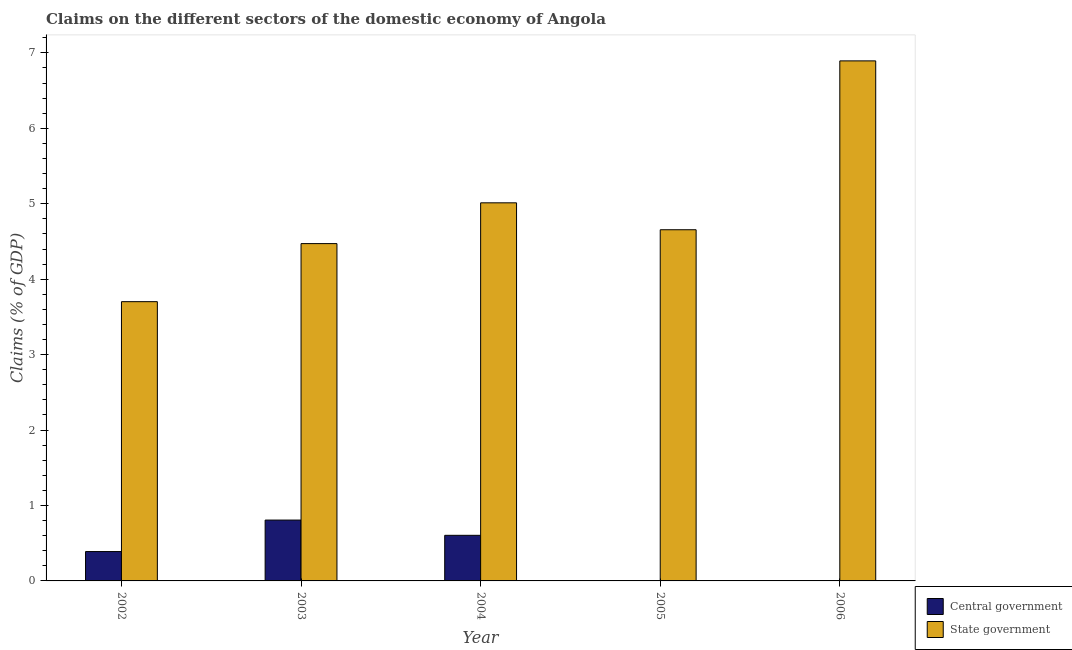How many different coloured bars are there?
Offer a terse response. 2. Are the number of bars on each tick of the X-axis equal?
Offer a very short reply. No. How many bars are there on the 4th tick from the left?
Provide a succinct answer. 1. In how many cases, is the number of bars for a given year not equal to the number of legend labels?
Ensure brevity in your answer.  2. What is the claims on state government in 2005?
Make the answer very short. 4.66. Across all years, what is the maximum claims on state government?
Make the answer very short. 6.89. What is the total claims on central government in the graph?
Give a very brief answer. 1.8. What is the difference between the claims on central government in 2002 and that in 2004?
Provide a succinct answer. -0.22. What is the difference between the claims on central government in 2005 and the claims on state government in 2002?
Give a very brief answer. -0.39. What is the average claims on state government per year?
Your response must be concise. 4.95. What is the ratio of the claims on central government in 2002 to that in 2003?
Your answer should be compact. 0.48. Is the difference between the claims on state government in 2002 and 2003 greater than the difference between the claims on central government in 2002 and 2003?
Provide a short and direct response. No. What is the difference between the highest and the second highest claims on central government?
Your answer should be very brief. 0.2. What is the difference between the highest and the lowest claims on central government?
Ensure brevity in your answer.  0.81. In how many years, is the claims on central government greater than the average claims on central government taken over all years?
Your answer should be compact. 3. How many bars are there?
Provide a succinct answer. 8. How many years are there in the graph?
Make the answer very short. 5. What is the difference between two consecutive major ticks on the Y-axis?
Keep it short and to the point. 1. What is the title of the graph?
Ensure brevity in your answer.  Claims on the different sectors of the domestic economy of Angola. Does "Highest 20% of population" appear as one of the legend labels in the graph?
Your response must be concise. No. What is the label or title of the Y-axis?
Your answer should be compact. Claims (% of GDP). What is the Claims (% of GDP) in Central government in 2002?
Offer a terse response. 0.39. What is the Claims (% of GDP) of State government in 2002?
Make the answer very short. 3.7. What is the Claims (% of GDP) of Central government in 2003?
Provide a succinct answer. 0.81. What is the Claims (% of GDP) in State government in 2003?
Your response must be concise. 4.47. What is the Claims (% of GDP) of Central government in 2004?
Offer a very short reply. 0.6. What is the Claims (% of GDP) in State government in 2004?
Give a very brief answer. 5.01. What is the Claims (% of GDP) of Central government in 2005?
Provide a succinct answer. 0. What is the Claims (% of GDP) of State government in 2005?
Your response must be concise. 4.66. What is the Claims (% of GDP) of Central government in 2006?
Offer a terse response. 0. What is the Claims (% of GDP) in State government in 2006?
Offer a terse response. 6.89. Across all years, what is the maximum Claims (% of GDP) in Central government?
Provide a short and direct response. 0.81. Across all years, what is the maximum Claims (% of GDP) in State government?
Offer a very short reply. 6.89. Across all years, what is the minimum Claims (% of GDP) of Central government?
Give a very brief answer. 0. Across all years, what is the minimum Claims (% of GDP) in State government?
Your answer should be very brief. 3.7. What is the total Claims (% of GDP) in Central government in the graph?
Offer a terse response. 1.8. What is the total Claims (% of GDP) in State government in the graph?
Offer a terse response. 24.74. What is the difference between the Claims (% of GDP) of Central government in 2002 and that in 2003?
Offer a terse response. -0.42. What is the difference between the Claims (% of GDP) of State government in 2002 and that in 2003?
Offer a very short reply. -0.77. What is the difference between the Claims (% of GDP) in Central government in 2002 and that in 2004?
Provide a short and direct response. -0.22. What is the difference between the Claims (% of GDP) of State government in 2002 and that in 2004?
Your answer should be very brief. -1.31. What is the difference between the Claims (% of GDP) in State government in 2002 and that in 2005?
Offer a very short reply. -0.95. What is the difference between the Claims (% of GDP) in State government in 2002 and that in 2006?
Make the answer very short. -3.19. What is the difference between the Claims (% of GDP) in Central government in 2003 and that in 2004?
Offer a very short reply. 0.2. What is the difference between the Claims (% of GDP) of State government in 2003 and that in 2004?
Keep it short and to the point. -0.54. What is the difference between the Claims (% of GDP) of State government in 2003 and that in 2005?
Give a very brief answer. -0.18. What is the difference between the Claims (% of GDP) of State government in 2003 and that in 2006?
Your response must be concise. -2.42. What is the difference between the Claims (% of GDP) in State government in 2004 and that in 2005?
Offer a very short reply. 0.36. What is the difference between the Claims (% of GDP) of State government in 2004 and that in 2006?
Offer a terse response. -1.88. What is the difference between the Claims (% of GDP) of State government in 2005 and that in 2006?
Ensure brevity in your answer.  -2.24. What is the difference between the Claims (% of GDP) in Central government in 2002 and the Claims (% of GDP) in State government in 2003?
Ensure brevity in your answer.  -4.08. What is the difference between the Claims (% of GDP) of Central government in 2002 and the Claims (% of GDP) of State government in 2004?
Offer a terse response. -4.62. What is the difference between the Claims (% of GDP) in Central government in 2002 and the Claims (% of GDP) in State government in 2005?
Offer a very short reply. -4.27. What is the difference between the Claims (% of GDP) of Central government in 2002 and the Claims (% of GDP) of State government in 2006?
Make the answer very short. -6.5. What is the difference between the Claims (% of GDP) of Central government in 2003 and the Claims (% of GDP) of State government in 2004?
Offer a very short reply. -4.21. What is the difference between the Claims (% of GDP) in Central government in 2003 and the Claims (% of GDP) in State government in 2005?
Your answer should be very brief. -3.85. What is the difference between the Claims (% of GDP) of Central government in 2003 and the Claims (% of GDP) of State government in 2006?
Keep it short and to the point. -6.09. What is the difference between the Claims (% of GDP) in Central government in 2004 and the Claims (% of GDP) in State government in 2005?
Your response must be concise. -4.05. What is the difference between the Claims (% of GDP) in Central government in 2004 and the Claims (% of GDP) in State government in 2006?
Keep it short and to the point. -6.29. What is the average Claims (% of GDP) of Central government per year?
Make the answer very short. 0.36. What is the average Claims (% of GDP) in State government per year?
Offer a terse response. 4.95. In the year 2002, what is the difference between the Claims (% of GDP) of Central government and Claims (% of GDP) of State government?
Offer a very short reply. -3.31. In the year 2003, what is the difference between the Claims (% of GDP) of Central government and Claims (% of GDP) of State government?
Offer a terse response. -3.67. In the year 2004, what is the difference between the Claims (% of GDP) in Central government and Claims (% of GDP) in State government?
Make the answer very short. -4.41. What is the ratio of the Claims (% of GDP) of Central government in 2002 to that in 2003?
Provide a short and direct response. 0.48. What is the ratio of the Claims (% of GDP) of State government in 2002 to that in 2003?
Provide a succinct answer. 0.83. What is the ratio of the Claims (% of GDP) of Central government in 2002 to that in 2004?
Keep it short and to the point. 0.64. What is the ratio of the Claims (% of GDP) of State government in 2002 to that in 2004?
Offer a terse response. 0.74. What is the ratio of the Claims (% of GDP) in State government in 2002 to that in 2005?
Your answer should be very brief. 0.8. What is the ratio of the Claims (% of GDP) in State government in 2002 to that in 2006?
Ensure brevity in your answer.  0.54. What is the ratio of the Claims (% of GDP) in Central government in 2003 to that in 2004?
Ensure brevity in your answer.  1.33. What is the ratio of the Claims (% of GDP) of State government in 2003 to that in 2004?
Provide a short and direct response. 0.89. What is the ratio of the Claims (% of GDP) of State government in 2003 to that in 2005?
Provide a short and direct response. 0.96. What is the ratio of the Claims (% of GDP) in State government in 2003 to that in 2006?
Give a very brief answer. 0.65. What is the ratio of the Claims (% of GDP) of State government in 2004 to that in 2005?
Your answer should be very brief. 1.08. What is the ratio of the Claims (% of GDP) in State government in 2004 to that in 2006?
Provide a short and direct response. 0.73. What is the ratio of the Claims (% of GDP) of State government in 2005 to that in 2006?
Offer a terse response. 0.68. What is the difference between the highest and the second highest Claims (% of GDP) in Central government?
Keep it short and to the point. 0.2. What is the difference between the highest and the second highest Claims (% of GDP) in State government?
Ensure brevity in your answer.  1.88. What is the difference between the highest and the lowest Claims (% of GDP) of Central government?
Keep it short and to the point. 0.81. What is the difference between the highest and the lowest Claims (% of GDP) in State government?
Provide a short and direct response. 3.19. 